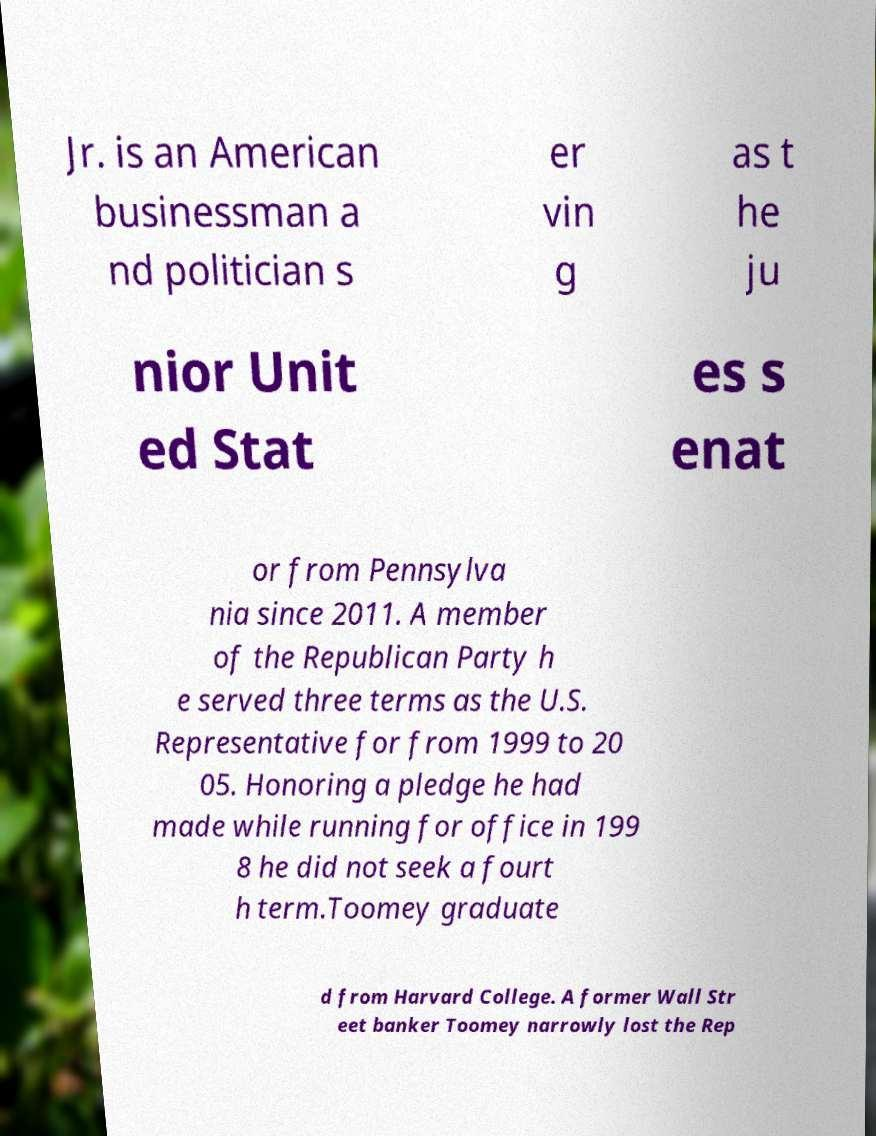Can you read and provide the text displayed in the image?This photo seems to have some interesting text. Can you extract and type it out for me? Jr. is an American businessman a nd politician s er vin g as t he ju nior Unit ed Stat es s enat or from Pennsylva nia since 2011. A member of the Republican Party h e served three terms as the U.S. Representative for from 1999 to 20 05. Honoring a pledge he had made while running for office in 199 8 he did not seek a fourt h term.Toomey graduate d from Harvard College. A former Wall Str eet banker Toomey narrowly lost the Rep 